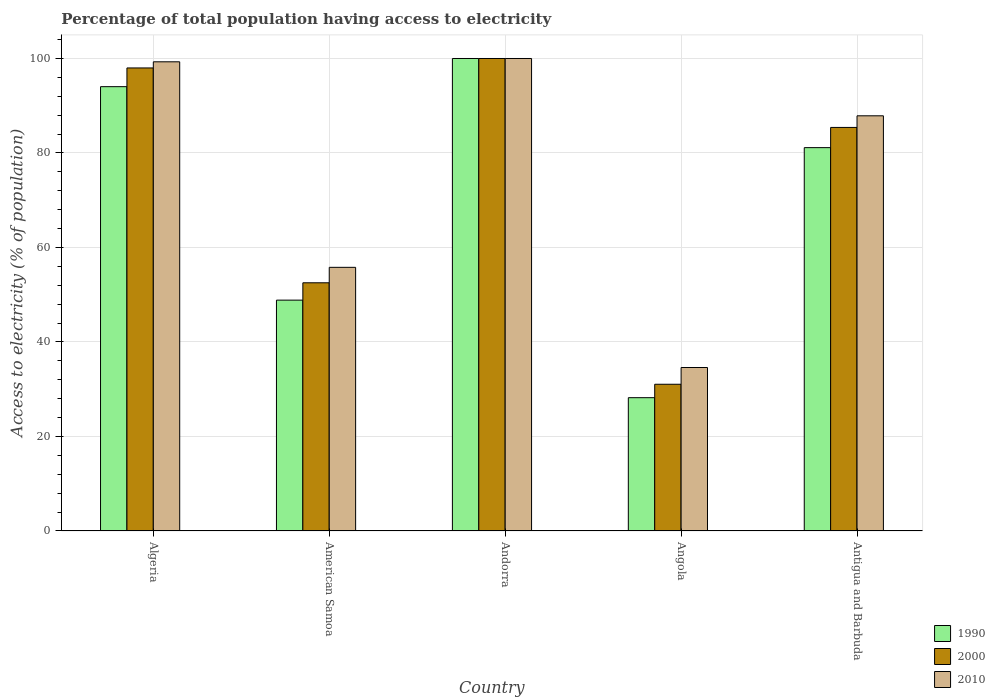How many groups of bars are there?
Offer a terse response. 5. Are the number of bars on each tick of the X-axis equal?
Keep it short and to the point. Yes. How many bars are there on the 3rd tick from the left?
Give a very brief answer. 3. What is the label of the 5th group of bars from the left?
Keep it short and to the point. Antigua and Barbuda. In how many cases, is the number of bars for a given country not equal to the number of legend labels?
Offer a terse response. 0. What is the percentage of population that have access to electricity in 2010 in Algeria?
Your answer should be very brief. 99.3. Across all countries, what is the minimum percentage of population that have access to electricity in 2010?
Your answer should be very brief. 34.6. In which country was the percentage of population that have access to electricity in 2010 maximum?
Offer a very short reply. Andorra. In which country was the percentage of population that have access to electricity in 1990 minimum?
Ensure brevity in your answer.  Angola. What is the total percentage of population that have access to electricity in 2000 in the graph?
Keep it short and to the point. 367. What is the difference between the percentage of population that have access to electricity in 2000 in Andorra and that in Angola?
Ensure brevity in your answer.  68.94. What is the difference between the percentage of population that have access to electricity in 1990 in Andorra and the percentage of population that have access to electricity in 2010 in Antigua and Barbuda?
Your response must be concise. 12.13. What is the average percentage of population that have access to electricity in 1990 per country?
Offer a very short reply. 70.45. What is the difference between the percentage of population that have access to electricity of/in 1990 and percentage of population that have access to electricity of/in 2000 in American Samoa?
Make the answer very short. -3.67. What is the ratio of the percentage of population that have access to electricity in 2010 in Andorra to that in Antigua and Barbuda?
Provide a succinct answer. 1.14. What is the difference between the highest and the second highest percentage of population that have access to electricity in 2010?
Offer a terse response. -0.7. What is the difference between the highest and the lowest percentage of population that have access to electricity in 1990?
Your response must be concise. 71.78. In how many countries, is the percentage of population that have access to electricity in 1990 greater than the average percentage of population that have access to electricity in 1990 taken over all countries?
Make the answer very short. 3. What does the 3rd bar from the right in American Samoa represents?
Your answer should be very brief. 1990. Is it the case that in every country, the sum of the percentage of population that have access to electricity in 2000 and percentage of population that have access to electricity in 2010 is greater than the percentage of population that have access to electricity in 1990?
Ensure brevity in your answer.  Yes. How many bars are there?
Keep it short and to the point. 15. Are all the bars in the graph horizontal?
Offer a terse response. No. How many countries are there in the graph?
Give a very brief answer. 5. What is the difference between two consecutive major ticks on the Y-axis?
Make the answer very short. 20. Where does the legend appear in the graph?
Keep it short and to the point. Bottom right. How many legend labels are there?
Your answer should be very brief. 3. What is the title of the graph?
Give a very brief answer. Percentage of total population having access to electricity. Does "1999" appear as one of the legend labels in the graph?
Your answer should be compact. No. What is the label or title of the X-axis?
Keep it short and to the point. Country. What is the label or title of the Y-axis?
Give a very brief answer. Access to electricity (% of population). What is the Access to electricity (% of population) in 1990 in Algeria?
Ensure brevity in your answer.  94.04. What is the Access to electricity (% of population) of 2000 in Algeria?
Give a very brief answer. 98. What is the Access to electricity (% of population) of 2010 in Algeria?
Give a very brief answer. 99.3. What is the Access to electricity (% of population) in 1990 in American Samoa?
Offer a terse response. 48.86. What is the Access to electricity (% of population) in 2000 in American Samoa?
Provide a succinct answer. 52.53. What is the Access to electricity (% of population) in 2010 in American Samoa?
Make the answer very short. 55.8. What is the Access to electricity (% of population) of 1990 in Angola?
Offer a very short reply. 28.22. What is the Access to electricity (% of population) in 2000 in Angola?
Your response must be concise. 31.06. What is the Access to electricity (% of population) of 2010 in Angola?
Offer a very short reply. 34.6. What is the Access to electricity (% of population) of 1990 in Antigua and Barbuda?
Your response must be concise. 81.14. What is the Access to electricity (% of population) in 2000 in Antigua and Barbuda?
Keep it short and to the point. 85.41. What is the Access to electricity (% of population) of 2010 in Antigua and Barbuda?
Your answer should be very brief. 87.87. Across all countries, what is the maximum Access to electricity (% of population) of 1990?
Your answer should be very brief. 100. Across all countries, what is the maximum Access to electricity (% of population) in 2000?
Your answer should be very brief. 100. Across all countries, what is the minimum Access to electricity (% of population) in 1990?
Offer a terse response. 28.22. Across all countries, what is the minimum Access to electricity (% of population) in 2000?
Offer a very short reply. 31.06. Across all countries, what is the minimum Access to electricity (% of population) of 2010?
Your response must be concise. 34.6. What is the total Access to electricity (% of population) in 1990 in the graph?
Offer a very short reply. 352.25. What is the total Access to electricity (% of population) in 2000 in the graph?
Ensure brevity in your answer.  367. What is the total Access to electricity (% of population) in 2010 in the graph?
Keep it short and to the point. 377.57. What is the difference between the Access to electricity (% of population) of 1990 in Algeria and that in American Samoa?
Ensure brevity in your answer.  45.18. What is the difference between the Access to electricity (% of population) of 2000 in Algeria and that in American Samoa?
Your response must be concise. 45.47. What is the difference between the Access to electricity (% of population) in 2010 in Algeria and that in American Samoa?
Keep it short and to the point. 43.5. What is the difference between the Access to electricity (% of population) of 1990 in Algeria and that in Andorra?
Your answer should be compact. -5.96. What is the difference between the Access to electricity (% of population) of 1990 in Algeria and that in Angola?
Your answer should be compact. 65.82. What is the difference between the Access to electricity (% of population) of 2000 in Algeria and that in Angola?
Keep it short and to the point. 66.94. What is the difference between the Access to electricity (% of population) of 2010 in Algeria and that in Angola?
Offer a terse response. 64.7. What is the difference between the Access to electricity (% of population) in 1990 in Algeria and that in Antigua and Barbuda?
Give a very brief answer. 12.9. What is the difference between the Access to electricity (% of population) in 2000 in Algeria and that in Antigua and Barbuda?
Provide a short and direct response. 12.59. What is the difference between the Access to electricity (% of population) in 2010 in Algeria and that in Antigua and Barbuda?
Keep it short and to the point. 11.43. What is the difference between the Access to electricity (% of population) in 1990 in American Samoa and that in Andorra?
Offer a very short reply. -51.14. What is the difference between the Access to electricity (% of population) of 2000 in American Samoa and that in Andorra?
Provide a succinct answer. -47.47. What is the difference between the Access to electricity (% of population) of 2010 in American Samoa and that in Andorra?
Provide a short and direct response. -44.2. What is the difference between the Access to electricity (% of population) of 1990 in American Samoa and that in Angola?
Provide a short and direct response. 20.64. What is the difference between the Access to electricity (% of population) of 2000 in American Samoa and that in Angola?
Ensure brevity in your answer.  21.47. What is the difference between the Access to electricity (% of population) of 2010 in American Samoa and that in Angola?
Your response must be concise. 21.2. What is the difference between the Access to electricity (% of population) of 1990 in American Samoa and that in Antigua and Barbuda?
Your response must be concise. -32.28. What is the difference between the Access to electricity (% of population) of 2000 in American Samoa and that in Antigua and Barbuda?
Your answer should be compact. -32.88. What is the difference between the Access to electricity (% of population) in 2010 in American Samoa and that in Antigua and Barbuda?
Provide a short and direct response. -32.07. What is the difference between the Access to electricity (% of population) of 1990 in Andorra and that in Angola?
Give a very brief answer. 71.78. What is the difference between the Access to electricity (% of population) in 2000 in Andorra and that in Angola?
Give a very brief answer. 68.94. What is the difference between the Access to electricity (% of population) of 2010 in Andorra and that in Angola?
Provide a succinct answer. 65.4. What is the difference between the Access to electricity (% of population) of 1990 in Andorra and that in Antigua and Barbuda?
Keep it short and to the point. 18.86. What is the difference between the Access to electricity (% of population) in 2000 in Andorra and that in Antigua and Barbuda?
Offer a very short reply. 14.59. What is the difference between the Access to electricity (% of population) in 2010 in Andorra and that in Antigua and Barbuda?
Give a very brief answer. 12.13. What is the difference between the Access to electricity (% of population) of 1990 in Angola and that in Antigua and Barbuda?
Offer a very short reply. -52.92. What is the difference between the Access to electricity (% of population) of 2000 in Angola and that in Antigua and Barbuda?
Offer a very short reply. -54.36. What is the difference between the Access to electricity (% of population) in 2010 in Angola and that in Antigua and Barbuda?
Keep it short and to the point. -53.27. What is the difference between the Access to electricity (% of population) in 1990 in Algeria and the Access to electricity (% of population) in 2000 in American Samoa?
Keep it short and to the point. 41.51. What is the difference between the Access to electricity (% of population) of 1990 in Algeria and the Access to electricity (% of population) of 2010 in American Samoa?
Provide a succinct answer. 38.24. What is the difference between the Access to electricity (% of population) of 2000 in Algeria and the Access to electricity (% of population) of 2010 in American Samoa?
Your answer should be very brief. 42.2. What is the difference between the Access to electricity (% of population) of 1990 in Algeria and the Access to electricity (% of population) of 2000 in Andorra?
Make the answer very short. -5.96. What is the difference between the Access to electricity (% of population) of 1990 in Algeria and the Access to electricity (% of population) of 2010 in Andorra?
Provide a succinct answer. -5.96. What is the difference between the Access to electricity (% of population) in 2000 in Algeria and the Access to electricity (% of population) in 2010 in Andorra?
Your response must be concise. -2. What is the difference between the Access to electricity (% of population) in 1990 in Algeria and the Access to electricity (% of population) in 2000 in Angola?
Offer a very short reply. 62.98. What is the difference between the Access to electricity (% of population) of 1990 in Algeria and the Access to electricity (% of population) of 2010 in Angola?
Ensure brevity in your answer.  59.44. What is the difference between the Access to electricity (% of population) in 2000 in Algeria and the Access to electricity (% of population) in 2010 in Angola?
Give a very brief answer. 63.4. What is the difference between the Access to electricity (% of population) of 1990 in Algeria and the Access to electricity (% of population) of 2000 in Antigua and Barbuda?
Keep it short and to the point. 8.63. What is the difference between the Access to electricity (% of population) of 1990 in Algeria and the Access to electricity (% of population) of 2010 in Antigua and Barbuda?
Offer a very short reply. 6.16. What is the difference between the Access to electricity (% of population) in 2000 in Algeria and the Access to electricity (% of population) in 2010 in Antigua and Barbuda?
Give a very brief answer. 10.13. What is the difference between the Access to electricity (% of population) of 1990 in American Samoa and the Access to electricity (% of population) of 2000 in Andorra?
Keep it short and to the point. -51.14. What is the difference between the Access to electricity (% of population) of 1990 in American Samoa and the Access to electricity (% of population) of 2010 in Andorra?
Make the answer very short. -51.14. What is the difference between the Access to electricity (% of population) in 2000 in American Samoa and the Access to electricity (% of population) in 2010 in Andorra?
Your answer should be compact. -47.47. What is the difference between the Access to electricity (% of population) of 1990 in American Samoa and the Access to electricity (% of population) of 2000 in Angola?
Give a very brief answer. 17.8. What is the difference between the Access to electricity (% of population) in 1990 in American Samoa and the Access to electricity (% of population) in 2010 in Angola?
Offer a terse response. 14.26. What is the difference between the Access to electricity (% of population) in 2000 in American Samoa and the Access to electricity (% of population) in 2010 in Angola?
Offer a very short reply. 17.93. What is the difference between the Access to electricity (% of population) of 1990 in American Samoa and the Access to electricity (% of population) of 2000 in Antigua and Barbuda?
Make the answer very short. -36.55. What is the difference between the Access to electricity (% of population) of 1990 in American Samoa and the Access to electricity (% of population) of 2010 in Antigua and Barbuda?
Make the answer very short. -39.01. What is the difference between the Access to electricity (% of population) of 2000 in American Samoa and the Access to electricity (% of population) of 2010 in Antigua and Barbuda?
Your response must be concise. -35.34. What is the difference between the Access to electricity (% of population) of 1990 in Andorra and the Access to electricity (% of population) of 2000 in Angola?
Provide a succinct answer. 68.94. What is the difference between the Access to electricity (% of population) of 1990 in Andorra and the Access to electricity (% of population) of 2010 in Angola?
Offer a very short reply. 65.4. What is the difference between the Access to electricity (% of population) in 2000 in Andorra and the Access to electricity (% of population) in 2010 in Angola?
Your answer should be compact. 65.4. What is the difference between the Access to electricity (% of population) of 1990 in Andorra and the Access to electricity (% of population) of 2000 in Antigua and Barbuda?
Keep it short and to the point. 14.59. What is the difference between the Access to electricity (% of population) in 1990 in Andorra and the Access to electricity (% of population) in 2010 in Antigua and Barbuda?
Ensure brevity in your answer.  12.13. What is the difference between the Access to electricity (% of population) of 2000 in Andorra and the Access to electricity (% of population) of 2010 in Antigua and Barbuda?
Provide a succinct answer. 12.13. What is the difference between the Access to electricity (% of population) of 1990 in Angola and the Access to electricity (% of population) of 2000 in Antigua and Barbuda?
Ensure brevity in your answer.  -57.2. What is the difference between the Access to electricity (% of population) of 1990 in Angola and the Access to electricity (% of population) of 2010 in Antigua and Barbuda?
Make the answer very short. -59.66. What is the difference between the Access to electricity (% of population) of 2000 in Angola and the Access to electricity (% of population) of 2010 in Antigua and Barbuda?
Ensure brevity in your answer.  -56.82. What is the average Access to electricity (% of population) of 1990 per country?
Your answer should be very brief. 70.45. What is the average Access to electricity (% of population) of 2000 per country?
Provide a short and direct response. 73.4. What is the average Access to electricity (% of population) in 2010 per country?
Offer a terse response. 75.51. What is the difference between the Access to electricity (% of population) of 1990 and Access to electricity (% of population) of 2000 in Algeria?
Your response must be concise. -3.96. What is the difference between the Access to electricity (% of population) of 1990 and Access to electricity (% of population) of 2010 in Algeria?
Provide a succinct answer. -5.26. What is the difference between the Access to electricity (% of population) in 2000 and Access to electricity (% of population) in 2010 in Algeria?
Your answer should be very brief. -1.3. What is the difference between the Access to electricity (% of population) in 1990 and Access to electricity (% of population) in 2000 in American Samoa?
Provide a short and direct response. -3.67. What is the difference between the Access to electricity (% of population) in 1990 and Access to electricity (% of population) in 2010 in American Samoa?
Provide a succinct answer. -6.94. What is the difference between the Access to electricity (% of population) in 2000 and Access to electricity (% of population) in 2010 in American Samoa?
Ensure brevity in your answer.  -3.27. What is the difference between the Access to electricity (% of population) in 2000 and Access to electricity (% of population) in 2010 in Andorra?
Offer a terse response. 0. What is the difference between the Access to electricity (% of population) in 1990 and Access to electricity (% of population) in 2000 in Angola?
Ensure brevity in your answer.  -2.84. What is the difference between the Access to electricity (% of population) of 1990 and Access to electricity (% of population) of 2010 in Angola?
Offer a very short reply. -6.38. What is the difference between the Access to electricity (% of population) of 2000 and Access to electricity (% of population) of 2010 in Angola?
Make the answer very short. -3.54. What is the difference between the Access to electricity (% of population) in 1990 and Access to electricity (% of population) in 2000 in Antigua and Barbuda?
Offer a very short reply. -4.28. What is the difference between the Access to electricity (% of population) of 1990 and Access to electricity (% of population) of 2010 in Antigua and Barbuda?
Provide a short and direct response. -6.74. What is the difference between the Access to electricity (% of population) in 2000 and Access to electricity (% of population) in 2010 in Antigua and Barbuda?
Offer a terse response. -2.46. What is the ratio of the Access to electricity (% of population) in 1990 in Algeria to that in American Samoa?
Keep it short and to the point. 1.92. What is the ratio of the Access to electricity (% of population) of 2000 in Algeria to that in American Samoa?
Ensure brevity in your answer.  1.87. What is the ratio of the Access to electricity (% of population) in 2010 in Algeria to that in American Samoa?
Make the answer very short. 1.78. What is the ratio of the Access to electricity (% of population) in 1990 in Algeria to that in Andorra?
Offer a terse response. 0.94. What is the ratio of the Access to electricity (% of population) in 2000 in Algeria to that in Andorra?
Give a very brief answer. 0.98. What is the ratio of the Access to electricity (% of population) of 2010 in Algeria to that in Andorra?
Keep it short and to the point. 0.99. What is the ratio of the Access to electricity (% of population) of 1990 in Algeria to that in Angola?
Your response must be concise. 3.33. What is the ratio of the Access to electricity (% of population) in 2000 in Algeria to that in Angola?
Your answer should be compact. 3.16. What is the ratio of the Access to electricity (% of population) of 2010 in Algeria to that in Angola?
Give a very brief answer. 2.87. What is the ratio of the Access to electricity (% of population) of 1990 in Algeria to that in Antigua and Barbuda?
Offer a very short reply. 1.16. What is the ratio of the Access to electricity (% of population) of 2000 in Algeria to that in Antigua and Barbuda?
Offer a terse response. 1.15. What is the ratio of the Access to electricity (% of population) of 2010 in Algeria to that in Antigua and Barbuda?
Give a very brief answer. 1.13. What is the ratio of the Access to electricity (% of population) of 1990 in American Samoa to that in Andorra?
Offer a very short reply. 0.49. What is the ratio of the Access to electricity (% of population) of 2000 in American Samoa to that in Andorra?
Ensure brevity in your answer.  0.53. What is the ratio of the Access to electricity (% of population) of 2010 in American Samoa to that in Andorra?
Offer a terse response. 0.56. What is the ratio of the Access to electricity (% of population) of 1990 in American Samoa to that in Angola?
Offer a very short reply. 1.73. What is the ratio of the Access to electricity (% of population) of 2000 in American Samoa to that in Angola?
Offer a very short reply. 1.69. What is the ratio of the Access to electricity (% of population) in 2010 in American Samoa to that in Angola?
Provide a succinct answer. 1.61. What is the ratio of the Access to electricity (% of population) in 1990 in American Samoa to that in Antigua and Barbuda?
Provide a short and direct response. 0.6. What is the ratio of the Access to electricity (% of population) in 2000 in American Samoa to that in Antigua and Barbuda?
Ensure brevity in your answer.  0.61. What is the ratio of the Access to electricity (% of population) in 2010 in American Samoa to that in Antigua and Barbuda?
Your answer should be very brief. 0.64. What is the ratio of the Access to electricity (% of population) in 1990 in Andorra to that in Angola?
Your answer should be very brief. 3.54. What is the ratio of the Access to electricity (% of population) of 2000 in Andorra to that in Angola?
Provide a succinct answer. 3.22. What is the ratio of the Access to electricity (% of population) of 2010 in Andorra to that in Angola?
Your response must be concise. 2.89. What is the ratio of the Access to electricity (% of population) of 1990 in Andorra to that in Antigua and Barbuda?
Offer a terse response. 1.23. What is the ratio of the Access to electricity (% of population) in 2000 in Andorra to that in Antigua and Barbuda?
Make the answer very short. 1.17. What is the ratio of the Access to electricity (% of population) in 2010 in Andorra to that in Antigua and Barbuda?
Offer a very short reply. 1.14. What is the ratio of the Access to electricity (% of population) of 1990 in Angola to that in Antigua and Barbuda?
Provide a succinct answer. 0.35. What is the ratio of the Access to electricity (% of population) of 2000 in Angola to that in Antigua and Barbuda?
Ensure brevity in your answer.  0.36. What is the ratio of the Access to electricity (% of population) in 2010 in Angola to that in Antigua and Barbuda?
Provide a succinct answer. 0.39. What is the difference between the highest and the second highest Access to electricity (% of population) of 1990?
Your answer should be compact. 5.96. What is the difference between the highest and the second highest Access to electricity (% of population) in 2000?
Offer a terse response. 2. What is the difference between the highest and the second highest Access to electricity (% of population) of 2010?
Make the answer very short. 0.7. What is the difference between the highest and the lowest Access to electricity (% of population) in 1990?
Provide a succinct answer. 71.78. What is the difference between the highest and the lowest Access to electricity (% of population) of 2000?
Offer a very short reply. 68.94. What is the difference between the highest and the lowest Access to electricity (% of population) of 2010?
Provide a succinct answer. 65.4. 